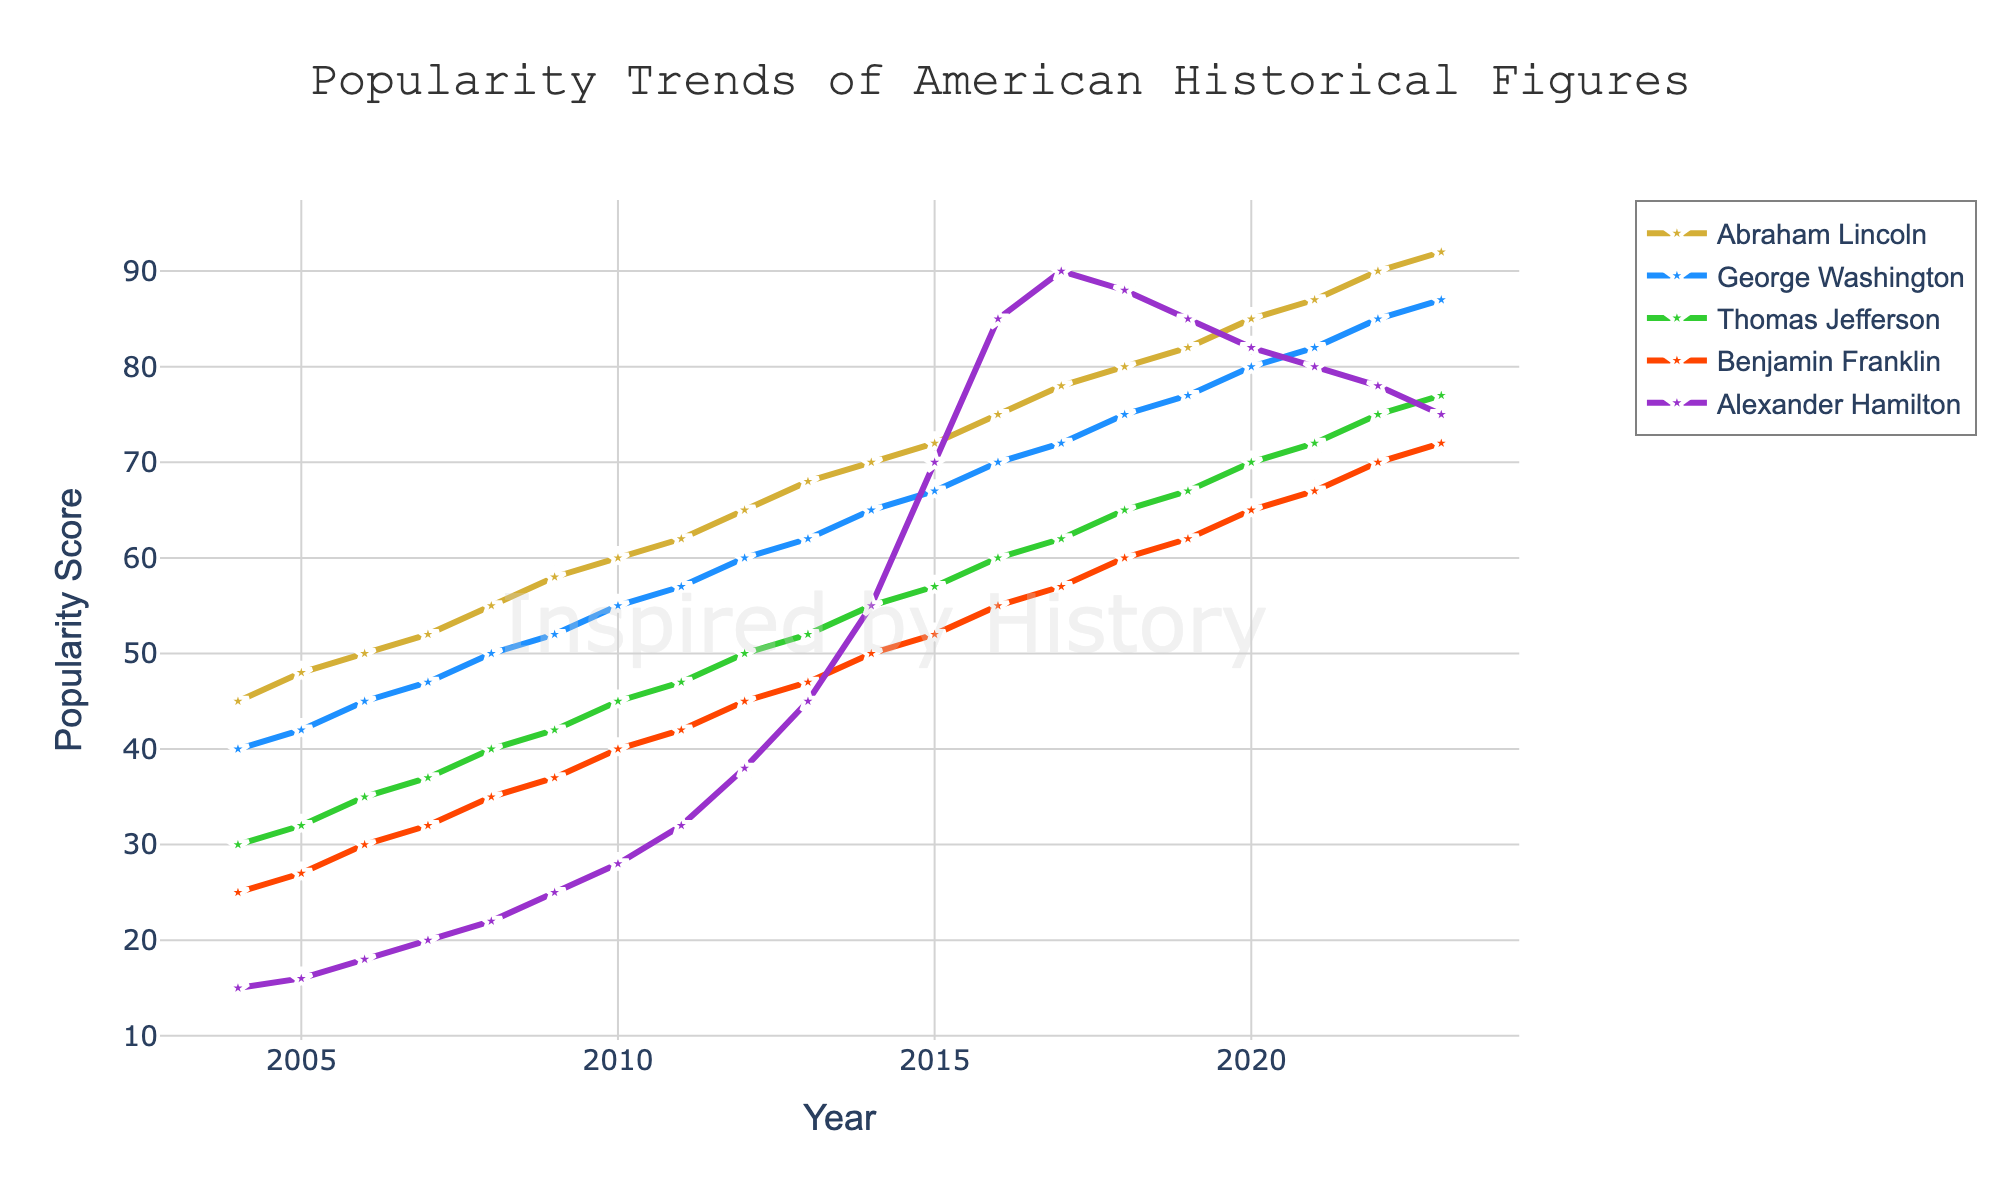What's the trend of Abraham Lincoln's popularity over the past 20 years? To determine this, observe the line representing Abraham Lincoln on the graph. It shows a consistent upward trend from 45 in 2004 to 92 in 2023.
Answer: Consistently increasing Between which years did Alexander Hamilton see the highest increase in popularity? Observe the slope of the line for Alexander Hamilton. The steepest slope is from 2014 to 2017, where the popularity score increased from 70 to 90.
Answer: 2014 to 2017 Who had higher popularity in 2012, Benjamin Franklin or Thomas Jefferson? Compare the value of the lines for Benjamin Franklin and Thomas Jefferson in the year 2012. Benjamin Franklin's score is 45 while Thomas Jefferson's is 50.
Answer: Thomas Jefferson What's the difference in popularity between George Washington and Alexander Hamilton in 2023? Compare the values of George Washington and Alexander Hamilton in 2023. George Washington has a popularity score of 87 whereas Alexander Hamilton has 75. Calculate 87 - 75.
Answer: 12 During which period did Benjamin Franklin's popularity increase by exactly 5 points every year? Examine the line for Benjamin Franklin, identifying a segment where it increases in equal steps of 5 each year. From 2008 (35) to 2011 (42), the increase is precisely 5 points each year.
Answer: 2008 to 2011 Which historical figure had a popularity score closest to 60 in 2014? Inspect the score for each figure in 2014. Abraham Lincoln has 70, George Washington has 65, Thomas Jefferson has 55, Benjamin Franklin has 50, and Alexander Hamilton has 55. The closest score to 60 is George Washington with 65.
Answer: George Washington What is the average popularity score of Thomas Jefferson in the years 2015, 2016, and 2017? Add the scores for Thomas Jefferson in 2015 (57), 2016 (60), and 2017 (62), then divide by 3: (57 + 60 + 62) / 3 = 179 / 3 = 59.67
Answer: 59.67 Who has the highest overall increase in popularity from 2004 to 2023? Determine the initial and final popularity scores for each figure: Abraham Lincoln (47), George Washington (47), Thomas Jefferson (47), Benjamin Franklin (25), and Alexander Hamilton (60). The highest increase is 60 for Alexander Hamilton.
Answer: Alexander Hamilton 